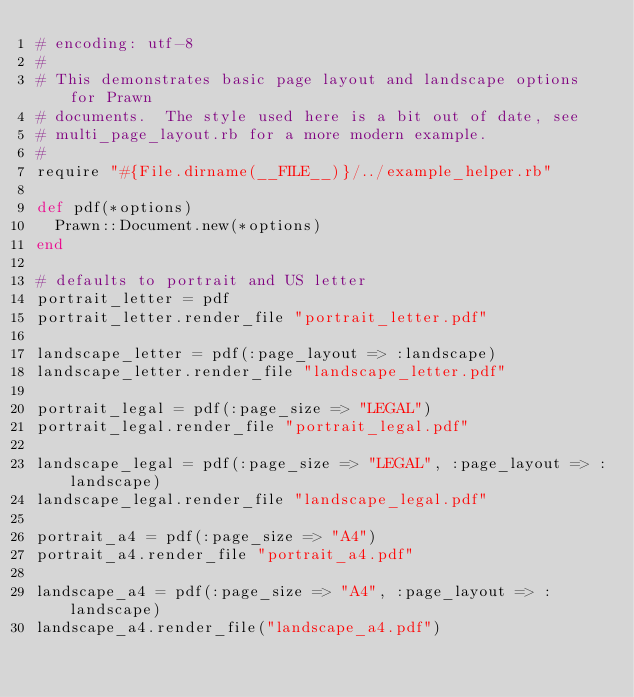<code> <loc_0><loc_0><loc_500><loc_500><_Ruby_># encoding: utf-8
#
# This demonstrates basic page layout and landscape options for Prawn
# documents.  The style used here is a bit out of date, see 
# multi_page_layout.rb for a more modern example.
#
require "#{File.dirname(__FILE__)}/../example_helper.rb"

def pdf(*options)  
  Prawn::Document.new(*options)
end
                                     
# defaults to portrait and US letter
portrait_letter = pdf 
portrait_letter.render_file "portrait_letter.pdf"

landscape_letter = pdf(:page_layout => :landscape)
landscape_letter.render_file "landscape_letter.pdf"  

portrait_legal = pdf(:page_size => "LEGAL")
portrait_legal.render_file "portrait_legal.pdf" 

landscape_legal = pdf(:page_size => "LEGAL", :page_layout => :landscape)
landscape_legal.render_file "landscape_legal.pdf"

portrait_a4 = pdf(:page_size => "A4")
portrait_a4.render_file "portrait_a4.pdf"

landscape_a4 = pdf(:page_size => "A4", :page_layout => :landscape)
landscape_a4.render_file("landscape_a4.pdf")

</code> 